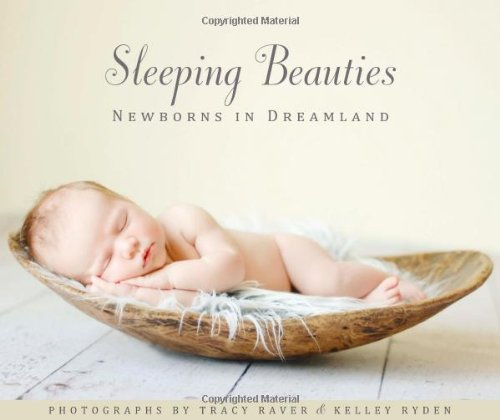What techniques were used to achieve the soft, dreamlike quality in the photos? To achieve the soft, dreamlike quality seen in the book's photos, techniques such as natural lighting, soft color palettes, and gentle post-processing are utilized, creating an ethereal and serene atmosphere around the sleeping newborns. 